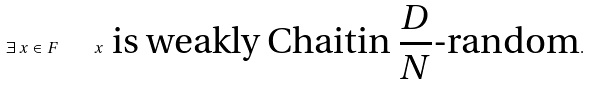<formula> <loc_0><loc_0><loc_500><loc_500>\exists \, x \in F \quad x \text { is weakly Chaitin $\frac{D}{N}$-random} .</formula> 